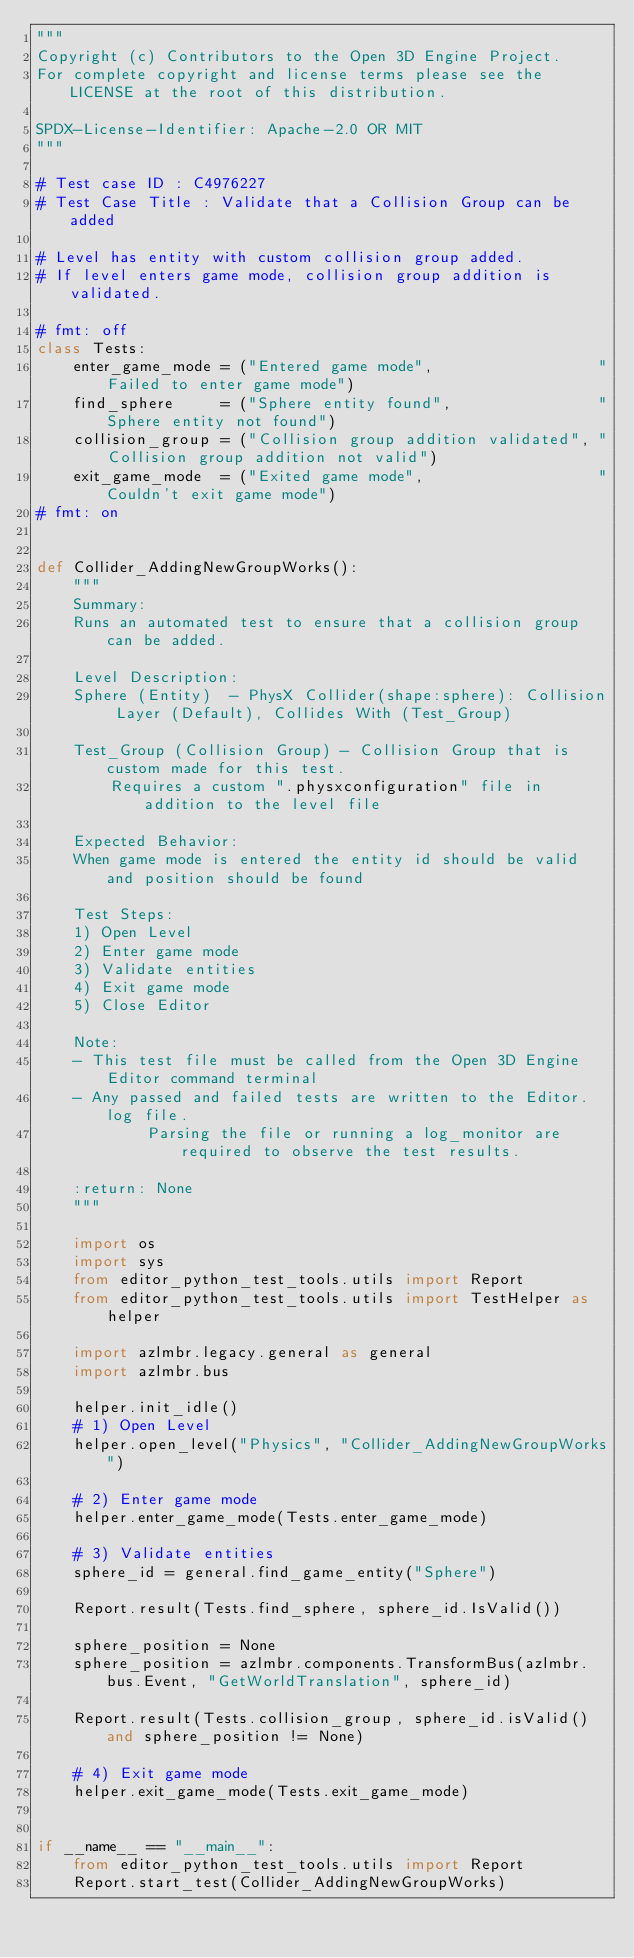<code> <loc_0><loc_0><loc_500><loc_500><_Python_>"""
Copyright (c) Contributors to the Open 3D Engine Project.
For complete copyright and license terms please see the LICENSE at the root of this distribution.

SPDX-License-Identifier: Apache-2.0 OR MIT
"""

# Test case ID : C4976227
# Test Case Title : Validate that a Collision Group can be added

# Level has entity with custom collision group added.
# If level enters game mode, collision group addition is validated.

# fmt: off
class Tests:
    enter_game_mode = ("Entered game mode",                  "Failed to enter game mode")
    find_sphere     = ("Sphere entity found",                "Sphere entity not found")
    collision_group = ("Collision group addition validated", "Collision group addition not valid")
    exit_game_mode  = ("Exited game mode",                   "Couldn't exit game mode")
# fmt: on


def Collider_AddingNewGroupWorks():
    """
    Summary:
    Runs an automated test to ensure that a collision group can be added.

    Level Description:
    Sphere (Entity)  - PhysX Collider(shape:sphere): Collision Layer (Default), Collides With (Test_Group)

    Test_Group (Collision Group) - Collision Group that is custom made for this test. 
        Requires a custom ".physxconfiguration" file in addition to the level file

    Expected Behavior:
    When game mode is entered the entity id should be valid and position should be found

    Test Steps:
    1) Open Level
    2) Enter game mode
    3) Validate entities
    4) Exit game mode
    5) Close Editor

    Note:
    - This test file must be called from the Open 3D Engine Editor command terminal
    - Any passed and failed tests are written to the Editor.log file.
            Parsing the file or running a log_monitor are required to observe the test results.

    :return: None
    """

    import os
    import sys
    from editor_python_test_tools.utils import Report
    from editor_python_test_tools.utils import TestHelper as helper

    import azlmbr.legacy.general as general
    import azlmbr.bus

    helper.init_idle()
    # 1) Open Level
    helper.open_level("Physics", "Collider_AddingNewGroupWorks")

    # 2) Enter game mode
    helper.enter_game_mode(Tests.enter_game_mode)

    # 3) Validate entities
    sphere_id = general.find_game_entity("Sphere")

    Report.result(Tests.find_sphere, sphere_id.IsValid())

    sphere_position = None
    sphere_position = azlmbr.components.TransformBus(azlmbr.bus.Event, "GetWorldTranslation", sphere_id)

    Report.result(Tests.collision_group, sphere_id.isValid() and sphere_position != None)

    # 4) Exit game mode
    helper.exit_game_mode(Tests.exit_game_mode)


if __name__ == "__main__":
    from editor_python_test_tools.utils import Report
    Report.start_test(Collider_AddingNewGroupWorks)
</code> 